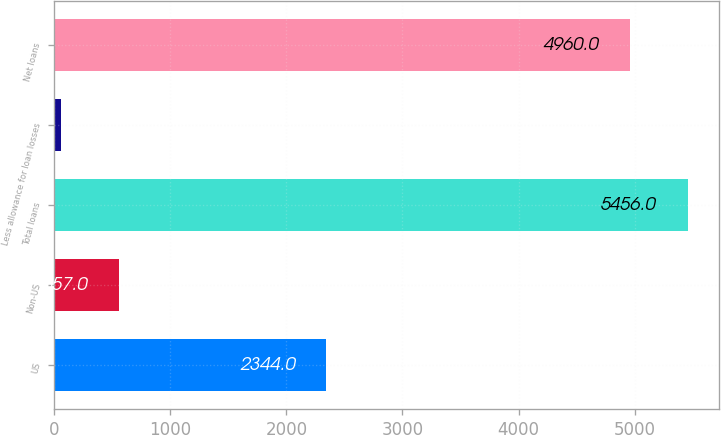Convert chart. <chart><loc_0><loc_0><loc_500><loc_500><bar_chart><fcel>US<fcel>Non-US<fcel>Total loans<fcel>Less allowance for loan losses<fcel>Net loans<nl><fcel>2344<fcel>557<fcel>5456<fcel>61<fcel>4960<nl></chart> 